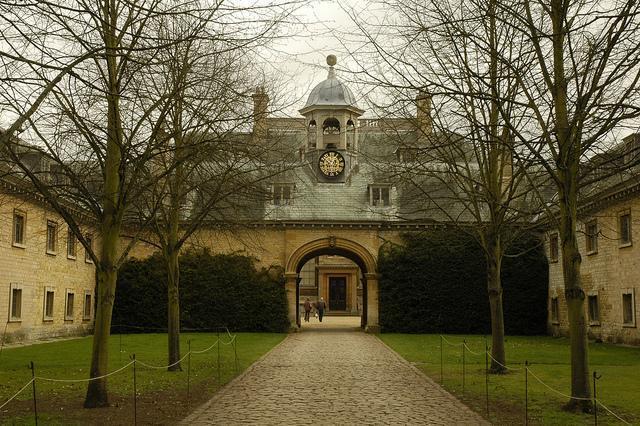What does this setting most resemble?
Indicate the correct response by choosing from the four available options to answer the question.
Options: College campus, tundra, circus, desert. College campus. 